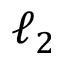<formula> <loc_0><loc_0><loc_500><loc_500>\ell _ { 2 }</formula> 